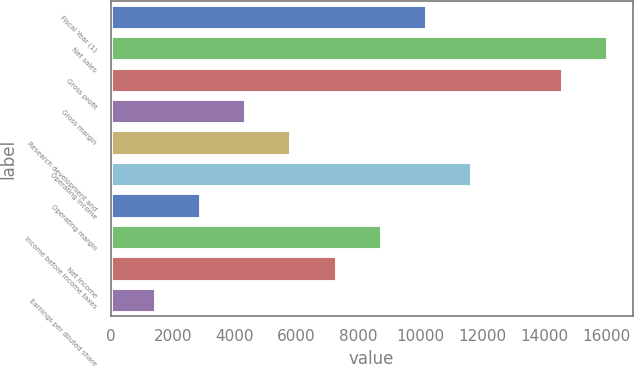<chart> <loc_0><loc_0><loc_500><loc_500><bar_chart><fcel>Fiscal Year (1)<fcel>Net sales<fcel>Gross profit<fcel>Gross margin<fcel>Research development and<fcel>Operating income<fcel>Operating margin<fcel>Income before income taxes<fcel>Net income<fcel>Earnings per diluted share<nl><fcel>10211.7<fcel>16046.8<fcel>14588<fcel>4376.68<fcel>5835.44<fcel>11670.5<fcel>2917.92<fcel>8752.96<fcel>7294.2<fcel>1459.16<nl></chart> 